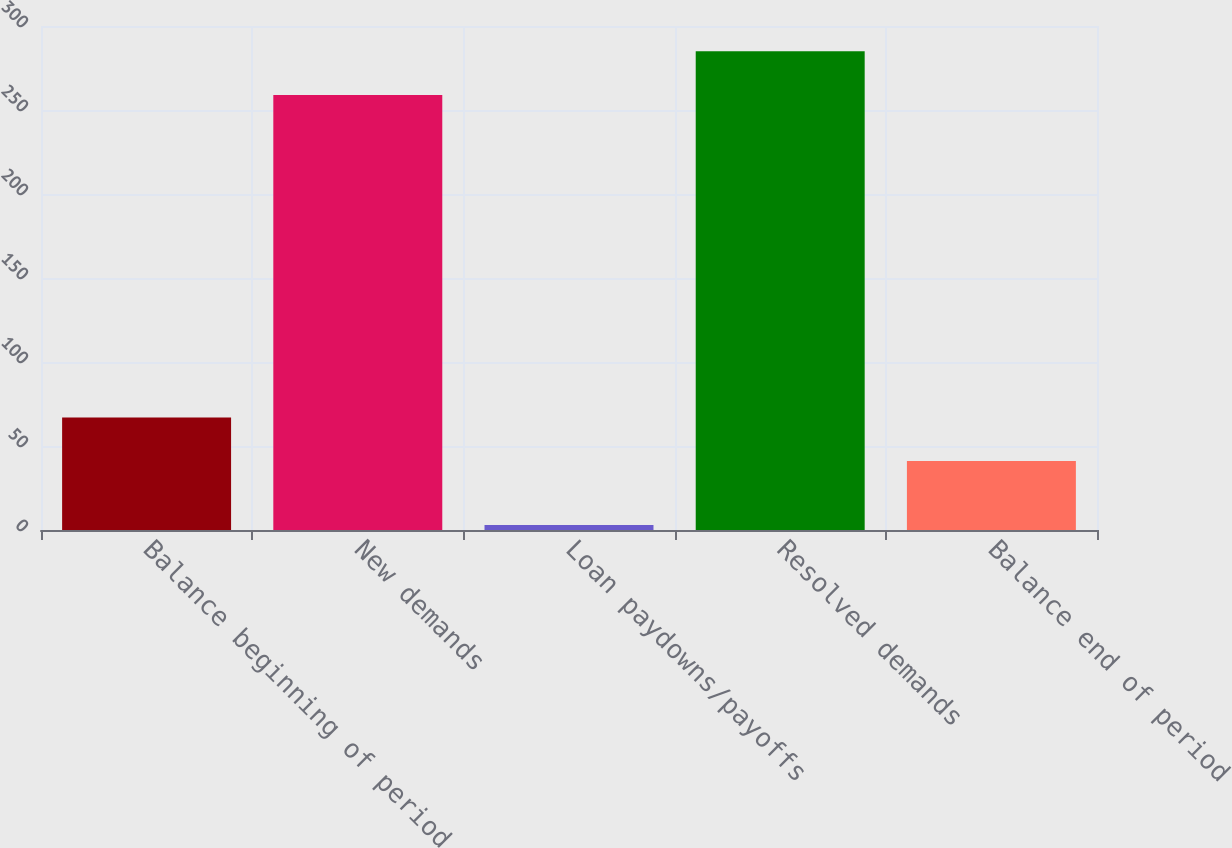<chart> <loc_0><loc_0><loc_500><loc_500><bar_chart><fcel>Balance beginning of period<fcel>New demands<fcel>Loan paydowns/payoffs<fcel>Resolved demands<fcel>Balance end of period<nl><fcel>67<fcel>259<fcel>3<fcel>285<fcel>41<nl></chart> 